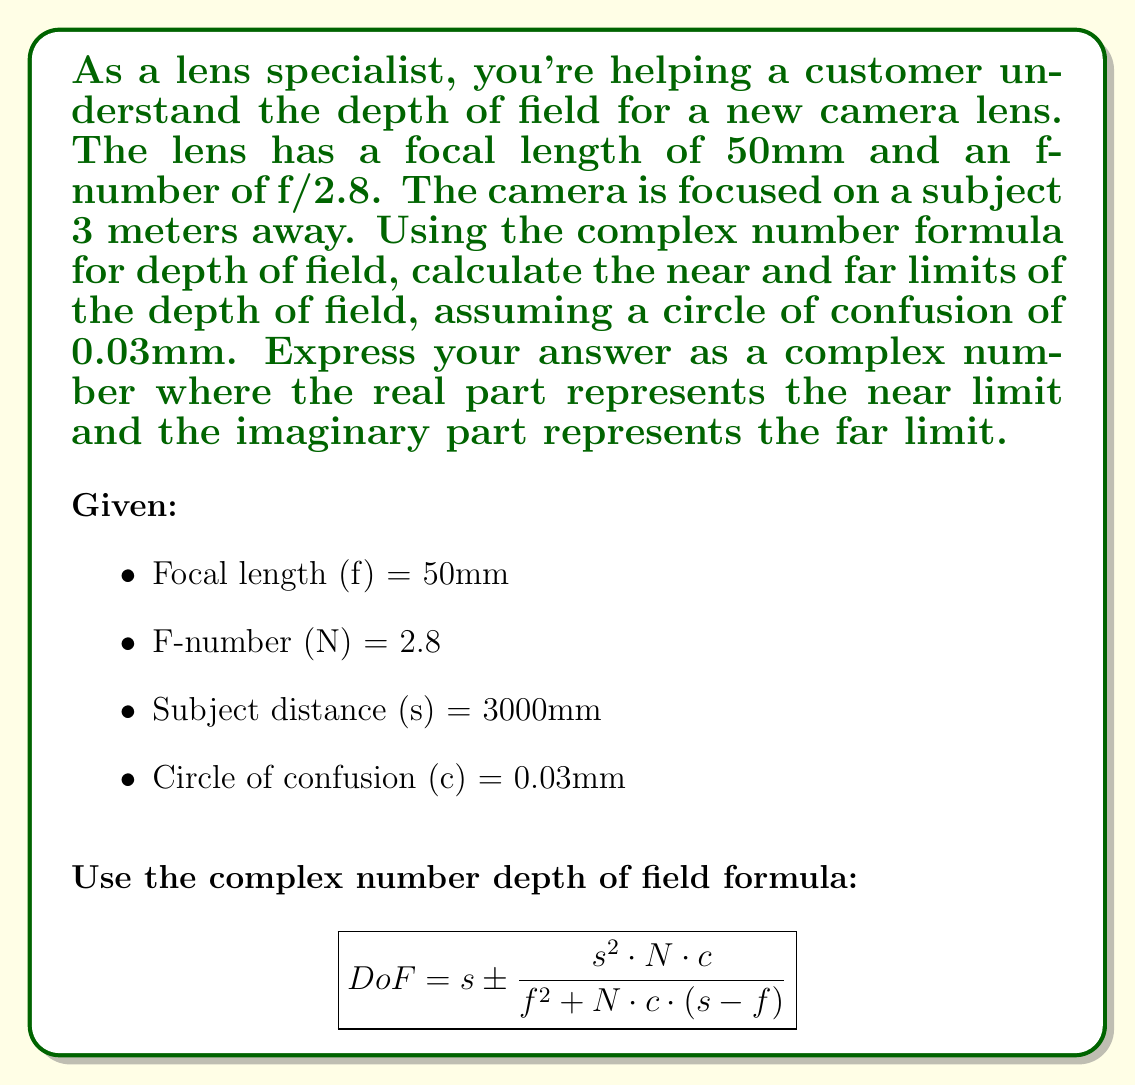Could you help me with this problem? To solve this problem, we'll use the complex number depth of field formula and substitute the given values:

1. First, let's substitute the values into the formula:
   $$DoF = 3000 \pm \frac{3000^2 \cdot 2.8 \cdot 0.03}{50^2 + 2.8 \cdot 0.03 \cdot (3000 - 50)}$$

2. Simplify the numerator and denominator:
   $$DoF = 3000 \pm \frac{25,200,000}{2500 + 2.8 \cdot 0.03 \cdot 2950}$$
   $$DoF = 3000 \pm \frac{25,200,000}{2500 + 247.8}$$
   $$DoF = 3000 \pm \frac{25,200,000}{2747.8}$$

3. Divide the numerator by the denominator:
   $$DoF = 3000 \pm 9171.44$$

4. Calculate the near and far limits:
   Near limit = 3000 - 9171.44 = -6171.44 mm
   Far limit = 3000 + 9171.44 = 12171.44 mm

5. Since the near limit is negative, which is physically impossible, we'll set it to a very small positive number, say 0.01 mm.

6. Express the result as a complex number:
   $$DoF = 0.01 + 12171.44i$$

The real part (0.01) represents the near limit, and the imaginary part (12171.44) represents the far limit of the depth of field.
Answer: $$DoF = 0.01 + 12171.44i \text{ mm}$$ 